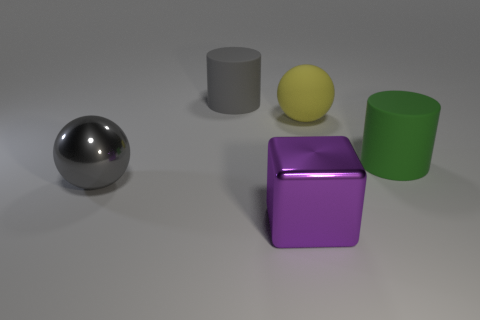Is there any other thing of the same color as the large metallic cube?
Your answer should be very brief. No. Is the size of the cylinder to the left of the yellow sphere the same as the ball that is to the right of the block?
Your answer should be very brief. Yes. There is a shiny thing that is to the right of the shiny thing on the left side of the big metallic block; what is its shape?
Offer a terse response. Cube. Do the gray cylinder and the purple cube in front of the big green rubber cylinder have the same size?
Your answer should be compact. Yes. What is the size of the metallic thing that is to the right of the large metallic thing to the left of the gray thing that is behind the large green cylinder?
Provide a succinct answer. Large. How many objects are either large spheres on the left side of the large purple shiny cube or rubber cylinders?
Your answer should be very brief. 3. How many shiny balls are right of the big rubber object behind the big yellow rubber sphere?
Your answer should be very brief. 0. Is the number of big gray things that are in front of the purple shiny block greater than the number of large purple cubes?
Give a very brief answer. No. How big is the object that is behind the big green rubber thing and in front of the big gray rubber object?
Keep it short and to the point. Large. There is a rubber thing that is behind the green matte cylinder and right of the purple shiny cube; what shape is it?
Provide a succinct answer. Sphere. 